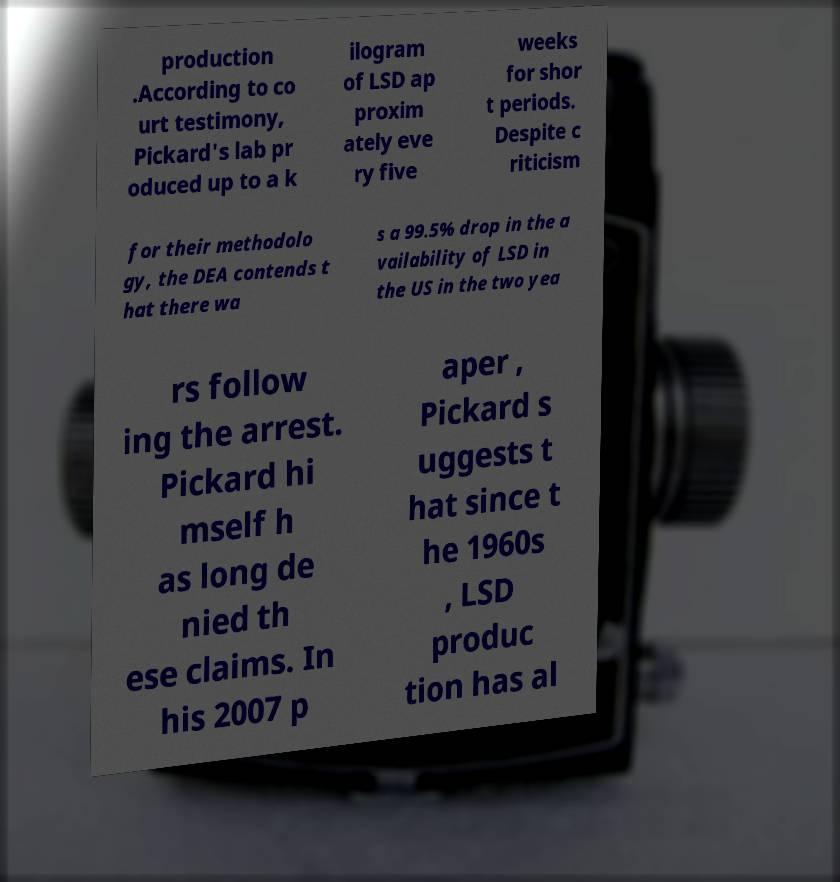I need the written content from this picture converted into text. Can you do that? production .According to co urt testimony, Pickard's lab pr oduced up to a k ilogram of LSD ap proxim ately eve ry five weeks for shor t periods. Despite c riticism for their methodolo gy, the DEA contends t hat there wa s a 99.5% drop in the a vailability of LSD in the US in the two yea rs follow ing the arrest. Pickard hi mself h as long de nied th ese claims. In his 2007 p aper , Pickard s uggests t hat since t he 1960s , LSD produc tion has al 